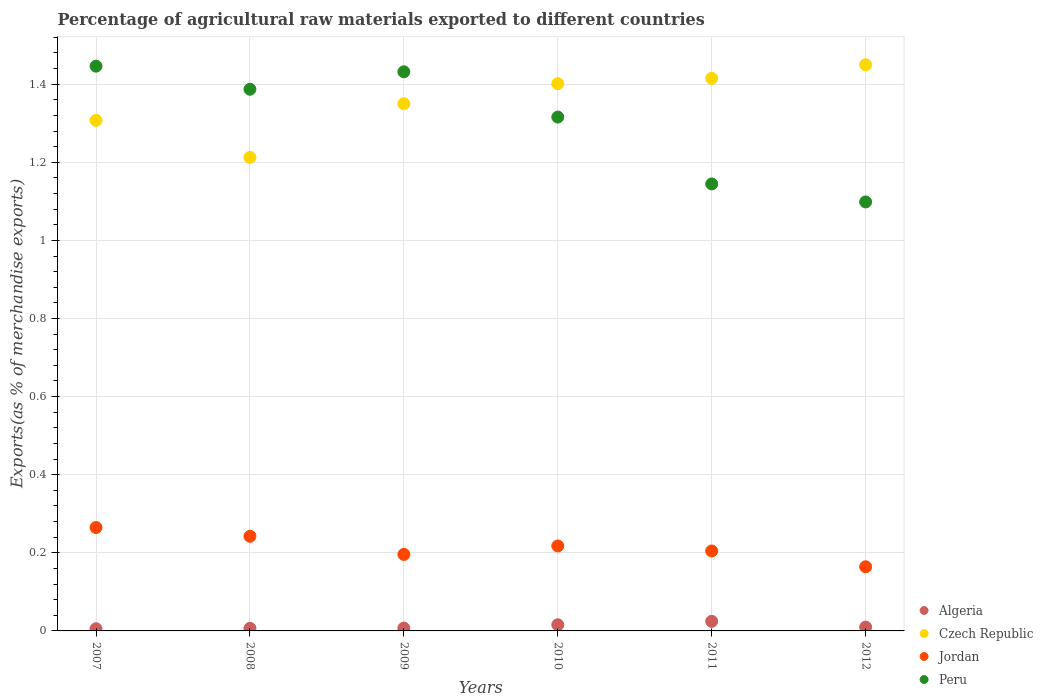How many different coloured dotlines are there?
Keep it short and to the point. 4. What is the percentage of exports to different countries in Czech Republic in 2012?
Offer a very short reply. 1.45. Across all years, what is the maximum percentage of exports to different countries in Czech Republic?
Give a very brief answer. 1.45. Across all years, what is the minimum percentage of exports to different countries in Czech Republic?
Provide a succinct answer. 1.21. In which year was the percentage of exports to different countries in Algeria maximum?
Make the answer very short. 2011. In which year was the percentage of exports to different countries in Czech Republic minimum?
Give a very brief answer. 2008. What is the total percentage of exports to different countries in Jordan in the graph?
Make the answer very short. 1.29. What is the difference between the percentage of exports to different countries in Algeria in 2007 and that in 2008?
Your answer should be compact. -0. What is the difference between the percentage of exports to different countries in Peru in 2011 and the percentage of exports to different countries in Jordan in 2010?
Provide a succinct answer. 0.93. What is the average percentage of exports to different countries in Czech Republic per year?
Your answer should be very brief. 1.36. In the year 2010, what is the difference between the percentage of exports to different countries in Algeria and percentage of exports to different countries in Peru?
Keep it short and to the point. -1.3. In how many years, is the percentage of exports to different countries in Peru greater than 0.56 %?
Your answer should be compact. 6. What is the ratio of the percentage of exports to different countries in Czech Republic in 2009 to that in 2010?
Give a very brief answer. 0.96. Is the difference between the percentage of exports to different countries in Algeria in 2007 and 2012 greater than the difference between the percentage of exports to different countries in Peru in 2007 and 2012?
Your response must be concise. No. What is the difference between the highest and the second highest percentage of exports to different countries in Jordan?
Your response must be concise. 0.02. What is the difference between the highest and the lowest percentage of exports to different countries in Jordan?
Your answer should be compact. 0.1. Is it the case that in every year, the sum of the percentage of exports to different countries in Peru and percentage of exports to different countries in Algeria  is greater than the sum of percentage of exports to different countries in Jordan and percentage of exports to different countries in Czech Republic?
Provide a short and direct response. No. Is the percentage of exports to different countries in Jordan strictly greater than the percentage of exports to different countries in Czech Republic over the years?
Offer a terse response. No. Is the percentage of exports to different countries in Czech Republic strictly less than the percentage of exports to different countries in Jordan over the years?
Your answer should be compact. No. What is the difference between two consecutive major ticks on the Y-axis?
Offer a very short reply. 0.2. Where does the legend appear in the graph?
Provide a short and direct response. Bottom right. How many legend labels are there?
Provide a short and direct response. 4. What is the title of the graph?
Offer a very short reply. Percentage of agricultural raw materials exported to different countries. What is the label or title of the X-axis?
Your response must be concise. Years. What is the label or title of the Y-axis?
Your answer should be compact. Exports(as % of merchandise exports). What is the Exports(as % of merchandise exports) in Algeria in 2007?
Provide a short and direct response. 0.01. What is the Exports(as % of merchandise exports) in Czech Republic in 2007?
Give a very brief answer. 1.31. What is the Exports(as % of merchandise exports) of Jordan in 2007?
Give a very brief answer. 0.26. What is the Exports(as % of merchandise exports) in Peru in 2007?
Offer a very short reply. 1.45. What is the Exports(as % of merchandise exports) in Algeria in 2008?
Offer a very short reply. 0.01. What is the Exports(as % of merchandise exports) of Czech Republic in 2008?
Make the answer very short. 1.21. What is the Exports(as % of merchandise exports) in Jordan in 2008?
Give a very brief answer. 0.24. What is the Exports(as % of merchandise exports) in Peru in 2008?
Offer a very short reply. 1.39. What is the Exports(as % of merchandise exports) of Algeria in 2009?
Your answer should be compact. 0.01. What is the Exports(as % of merchandise exports) of Czech Republic in 2009?
Give a very brief answer. 1.35. What is the Exports(as % of merchandise exports) of Jordan in 2009?
Give a very brief answer. 0.2. What is the Exports(as % of merchandise exports) of Peru in 2009?
Provide a short and direct response. 1.43. What is the Exports(as % of merchandise exports) of Algeria in 2010?
Offer a terse response. 0.02. What is the Exports(as % of merchandise exports) of Czech Republic in 2010?
Keep it short and to the point. 1.4. What is the Exports(as % of merchandise exports) of Jordan in 2010?
Offer a terse response. 0.22. What is the Exports(as % of merchandise exports) of Peru in 2010?
Provide a short and direct response. 1.32. What is the Exports(as % of merchandise exports) of Algeria in 2011?
Provide a short and direct response. 0.02. What is the Exports(as % of merchandise exports) in Czech Republic in 2011?
Your answer should be compact. 1.41. What is the Exports(as % of merchandise exports) of Jordan in 2011?
Give a very brief answer. 0.2. What is the Exports(as % of merchandise exports) of Peru in 2011?
Provide a short and direct response. 1.14. What is the Exports(as % of merchandise exports) in Algeria in 2012?
Offer a very short reply. 0.01. What is the Exports(as % of merchandise exports) of Czech Republic in 2012?
Provide a succinct answer. 1.45. What is the Exports(as % of merchandise exports) in Jordan in 2012?
Make the answer very short. 0.16. What is the Exports(as % of merchandise exports) of Peru in 2012?
Offer a very short reply. 1.1. Across all years, what is the maximum Exports(as % of merchandise exports) of Algeria?
Your response must be concise. 0.02. Across all years, what is the maximum Exports(as % of merchandise exports) of Czech Republic?
Offer a terse response. 1.45. Across all years, what is the maximum Exports(as % of merchandise exports) of Jordan?
Offer a terse response. 0.26. Across all years, what is the maximum Exports(as % of merchandise exports) in Peru?
Keep it short and to the point. 1.45. Across all years, what is the minimum Exports(as % of merchandise exports) in Algeria?
Offer a terse response. 0.01. Across all years, what is the minimum Exports(as % of merchandise exports) in Czech Republic?
Make the answer very short. 1.21. Across all years, what is the minimum Exports(as % of merchandise exports) of Jordan?
Provide a succinct answer. 0.16. Across all years, what is the minimum Exports(as % of merchandise exports) of Peru?
Offer a terse response. 1.1. What is the total Exports(as % of merchandise exports) in Algeria in the graph?
Your response must be concise. 0.07. What is the total Exports(as % of merchandise exports) in Czech Republic in the graph?
Offer a very short reply. 8.14. What is the total Exports(as % of merchandise exports) in Jordan in the graph?
Provide a succinct answer. 1.29. What is the total Exports(as % of merchandise exports) of Peru in the graph?
Your answer should be very brief. 7.82. What is the difference between the Exports(as % of merchandise exports) in Algeria in 2007 and that in 2008?
Your answer should be very brief. -0. What is the difference between the Exports(as % of merchandise exports) in Czech Republic in 2007 and that in 2008?
Offer a terse response. 0.1. What is the difference between the Exports(as % of merchandise exports) in Jordan in 2007 and that in 2008?
Offer a very short reply. 0.02. What is the difference between the Exports(as % of merchandise exports) in Peru in 2007 and that in 2008?
Make the answer very short. 0.06. What is the difference between the Exports(as % of merchandise exports) in Algeria in 2007 and that in 2009?
Provide a succinct answer. -0. What is the difference between the Exports(as % of merchandise exports) of Czech Republic in 2007 and that in 2009?
Provide a succinct answer. -0.04. What is the difference between the Exports(as % of merchandise exports) of Jordan in 2007 and that in 2009?
Give a very brief answer. 0.07. What is the difference between the Exports(as % of merchandise exports) in Peru in 2007 and that in 2009?
Ensure brevity in your answer.  0.01. What is the difference between the Exports(as % of merchandise exports) of Algeria in 2007 and that in 2010?
Provide a succinct answer. -0.01. What is the difference between the Exports(as % of merchandise exports) in Czech Republic in 2007 and that in 2010?
Make the answer very short. -0.09. What is the difference between the Exports(as % of merchandise exports) of Jordan in 2007 and that in 2010?
Offer a terse response. 0.05. What is the difference between the Exports(as % of merchandise exports) of Peru in 2007 and that in 2010?
Ensure brevity in your answer.  0.13. What is the difference between the Exports(as % of merchandise exports) in Algeria in 2007 and that in 2011?
Your answer should be very brief. -0.02. What is the difference between the Exports(as % of merchandise exports) of Czech Republic in 2007 and that in 2011?
Your answer should be compact. -0.11. What is the difference between the Exports(as % of merchandise exports) of Jordan in 2007 and that in 2011?
Ensure brevity in your answer.  0.06. What is the difference between the Exports(as % of merchandise exports) in Peru in 2007 and that in 2011?
Keep it short and to the point. 0.3. What is the difference between the Exports(as % of merchandise exports) of Algeria in 2007 and that in 2012?
Ensure brevity in your answer.  -0. What is the difference between the Exports(as % of merchandise exports) of Czech Republic in 2007 and that in 2012?
Offer a very short reply. -0.14. What is the difference between the Exports(as % of merchandise exports) of Jordan in 2007 and that in 2012?
Provide a short and direct response. 0.1. What is the difference between the Exports(as % of merchandise exports) in Peru in 2007 and that in 2012?
Keep it short and to the point. 0.35. What is the difference between the Exports(as % of merchandise exports) of Algeria in 2008 and that in 2009?
Offer a terse response. -0. What is the difference between the Exports(as % of merchandise exports) of Czech Republic in 2008 and that in 2009?
Give a very brief answer. -0.14. What is the difference between the Exports(as % of merchandise exports) in Jordan in 2008 and that in 2009?
Your answer should be compact. 0.05. What is the difference between the Exports(as % of merchandise exports) in Peru in 2008 and that in 2009?
Ensure brevity in your answer.  -0.04. What is the difference between the Exports(as % of merchandise exports) in Algeria in 2008 and that in 2010?
Provide a short and direct response. -0.01. What is the difference between the Exports(as % of merchandise exports) in Czech Republic in 2008 and that in 2010?
Your response must be concise. -0.19. What is the difference between the Exports(as % of merchandise exports) in Jordan in 2008 and that in 2010?
Offer a very short reply. 0.02. What is the difference between the Exports(as % of merchandise exports) of Peru in 2008 and that in 2010?
Your answer should be compact. 0.07. What is the difference between the Exports(as % of merchandise exports) of Algeria in 2008 and that in 2011?
Your answer should be compact. -0.02. What is the difference between the Exports(as % of merchandise exports) of Czech Republic in 2008 and that in 2011?
Your response must be concise. -0.2. What is the difference between the Exports(as % of merchandise exports) in Jordan in 2008 and that in 2011?
Offer a very short reply. 0.04. What is the difference between the Exports(as % of merchandise exports) in Peru in 2008 and that in 2011?
Offer a very short reply. 0.24. What is the difference between the Exports(as % of merchandise exports) of Algeria in 2008 and that in 2012?
Your answer should be very brief. -0. What is the difference between the Exports(as % of merchandise exports) in Czech Republic in 2008 and that in 2012?
Keep it short and to the point. -0.24. What is the difference between the Exports(as % of merchandise exports) of Jordan in 2008 and that in 2012?
Keep it short and to the point. 0.08. What is the difference between the Exports(as % of merchandise exports) of Peru in 2008 and that in 2012?
Provide a short and direct response. 0.29. What is the difference between the Exports(as % of merchandise exports) in Algeria in 2009 and that in 2010?
Make the answer very short. -0.01. What is the difference between the Exports(as % of merchandise exports) of Czech Republic in 2009 and that in 2010?
Your answer should be very brief. -0.05. What is the difference between the Exports(as % of merchandise exports) in Jordan in 2009 and that in 2010?
Offer a very short reply. -0.02. What is the difference between the Exports(as % of merchandise exports) in Peru in 2009 and that in 2010?
Offer a terse response. 0.12. What is the difference between the Exports(as % of merchandise exports) of Algeria in 2009 and that in 2011?
Keep it short and to the point. -0.02. What is the difference between the Exports(as % of merchandise exports) of Czech Republic in 2009 and that in 2011?
Provide a short and direct response. -0.06. What is the difference between the Exports(as % of merchandise exports) of Jordan in 2009 and that in 2011?
Keep it short and to the point. -0.01. What is the difference between the Exports(as % of merchandise exports) of Peru in 2009 and that in 2011?
Make the answer very short. 0.29. What is the difference between the Exports(as % of merchandise exports) of Algeria in 2009 and that in 2012?
Offer a very short reply. -0. What is the difference between the Exports(as % of merchandise exports) of Czech Republic in 2009 and that in 2012?
Provide a succinct answer. -0.1. What is the difference between the Exports(as % of merchandise exports) of Jordan in 2009 and that in 2012?
Your answer should be compact. 0.03. What is the difference between the Exports(as % of merchandise exports) in Algeria in 2010 and that in 2011?
Your response must be concise. -0.01. What is the difference between the Exports(as % of merchandise exports) in Czech Republic in 2010 and that in 2011?
Offer a terse response. -0.01. What is the difference between the Exports(as % of merchandise exports) of Jordan in 2010 and that in 2011?
Offer a terse response. 0.01. What is the difference between the Exports(as % of merchandise exports) in Peru in 2010 and that in 2011?
Your answer should be very brief. 0.17. What is the difference between the Exports(as % of merchandise exports) in Algeria in 2010 and that in 2012?
Make the answer very short. 0.01. What is the difference between the Exports(as % of merchandise exports) of Czech Republic in 2010 and that in 2012?
Your response must be concise. -0.05. What is the difference between the Exports(as % of merchandise exports) of Jordan in 2010 and that in 2012?
Make the answer very short. 0.05. What is the difference between the Exports(as % of merchandise exports) of Peru in 2010 and that in 2012?
Ensure brevity in your answer.  0.22. What is the difference between the Exports(as % of merchandise exports) of Algeria in 2011 and that in 2012?
Give a very brief answer. 0.01. What is the difference between the Exports(as % of merchandise exports) of Czech Republic in 2011 and that in 2012?
Give a very brief answer. -0.03. What is the difference between the Exports(as % of merchandise exports) in Jordan in 2011 and that in 2012?
Ensure brevity in your answer.  0.04. What is the difference between the Exports(as % of merchandise exports) of Peru in 2011 and that in 2012?
Ensure brevity in your answer.  0.05. What is the difference between the Exports(as % of merchandise exports) of Algeria in 2007 and the Exports(as % of merchandise exports) of Czech Republic in 2008?
Provide a short and direct response. -1.21. What is the difference between the Exports(as % of merchandise exports) of Algeria in 2007 and the Exports(as % of merchandise exports) of Jordan in 2008?
Offer a terse response. -0.24. What is the difference between the Exports(as % of merchandise exports) in Algeria in 2007 and the Exports(as % of merchandise exports) in Peru in 2008?
Offer a very short reply. -1.38. What is the difference between the Exports(as % of merchandise exports) in Czech Republic in 2007 and the Exports(as % of merchandise exports) in Jordan in 2008?
Provide a short and direct response. 1.07. What is the difference between the Exports(as % of merchandise exports) of Czech Republic in 2007 and the Exports(as % of merchandise exports) of Peru in 2008?
Give a very brief answer. -0.08. What is the difference between the Exports(as % of merchandise exports) in Jordan in 2007 and the Exports(as % of merchandise exports) in Peru in 2008?
Give a very brief answer. -1.12. What is the difference between the Exports(as % of merchandise exports) in Algeria in 2007 and the Exports(as % of merchandise exports) in Czech Republic in 2009?
Make the answer very short. -1.34. What is the difference between the Exports(as % of merchandise exports) in Algeria in 2007 and the Exports(as % of merchandise exports) in Jordan in 2009?
Make the answer very short. -0.19. What is the difference between the Exports(as % of merchandise exports) of Algeria in 2007 and the Exports(as % of merchandise exports) of Peru in 2009?
Provide a succinct answer. -1.43. What is the difference between the Exports(as % of merchandise exports) in Czech Republic in 2007 and the Exports(as % of merchandise exports) in Jordan in 2009?
Your response must be concise. 1.11. What is the difference between the Exports(as % of merchandise exports) of Czech Republic in 2007 and the Exports(as % of merchandise exports) of Peru in 2009?
Provide a succinct answer. -0.12. What is the difference between the Exports(as % of merchandise exports) in Jordan in 2007 and the Exports(as % of merchandise exports) in Peru in 2009?
Provide a short and direct response. -1.17. What is the difference between the Exports(as % of merchandise exports) in Algeria in 2007 and the Exports(as % of merchandise exports) in Czech Republic in 2010?
Your response must be concise. -1.4. What is the difference between the Exports(as % of merchandise exports) of Algeria in 2007 and the Exports(as % of merchandise exports) of Jordan in 2010?
Make the answer very short. -0.21. What is the difference between the Exports(as % of merchandise exports) of Algeria in 2007 and the Exports(as % of merchandise exports) of Peru in 2010?
Make the answer very short. -1.31. What is the difference between the Exports(as % of merchandise exports) in Czech Republic in 2007 and the Exports(as % of merchandise exports) in Jordan in 2010?
Ensure brevity in your answer.  1.09. What is the difference between the Exports(as % of merchandise exports) in Czech Republic in 2007 and the Exports(as % of merchandise exports) in Peru in 2010?
Your answer should be very brief. -0.01. What is the difference between the Exports(as % of merchandise exports) of Jordan in 2007 and the Exports(as % of merchandise exports) of Peru in 2010?
Offer a terse response. -1.05. What is the difference between the Exports(as % of merchandise exports) in Algeria in 2007 and the Exports(as % of merchandise exports) in Czech Republic in 2011?
Offer a very short reply. -1.41. What is the difference between the Exports(as % of merchandise exports) of Algeria in 2007 and the Exports(as % of merchandise exports) of Jordan in 2011?
Ensure brevity in your answer.  -0.2. What is the difference between the Exports(as % of merchandise exports) of Algeria in 2007 and the Exports(as % of merchandise exports) of Peru in 2011?
Ensure brevity in your answer.  -1.14. What is the difference between the Exports(as % of merchandise exports) of Czech Republic in 2007 and the Exports(as % of merchandise exports) of Jordan in 2011?
Offer a terse response. 1.1. What is the difference between the Exports(as % of merchandise exports) of Czech Republic in 2007 and the Exports(as % of merchandise exports) of Peru in 2011?
Offer a very short reply. 0.16. What is the difference between the Exports(as % of merchandise exports) of Jordan in 2007 and the Exports(as % of merchandise exports) of Peru in 2011?
Ensure brevity in your answer.  -0.88. What is the difference between the Exports(as % of merchandise exports) in Algeria in 2007 and the Exports(as % of merchandise exports) in Czech Republic in 2012?
Your answer should be very brief. -1.44. What is the difference between the Exports(as % of merchandise exports) of Algeria in 2007 and the Exports(as % of merchandise exports) of Jordan in 2012?
Give a very brief answer. -0.16. What is the difference between the Exports(as % of merchandise exports) of Algeria in 2007 and the Exports(as % of merchandise exports) of Peru in 2012?
Make the answer very short. -1.09. What is the difference between the Exports(as % of merchandise exports) in Czech Republic in 2007 and the Exports(as % of merchandise exports) in Jordan in 2012?
Offer a terse response. 1.14. What is the difference between the Exports(as % of merchandise exports) of Czech Republic in 2007 and the Exports(as % of merchandise exports) of Peru in 2012?
Offer a very short reply. 0.21. What is the difference between the Exports(as % of merchandise exports) in Jordan in 2007 and the Exports(as % of merchandise exports) in Peru in 2012?
Your answer should be compact. -0.83. What is the difference between the Exports(as % of merchandise exports) in Algeria in 2008 and the Exports(as % of merchandise exports) in Czech Republic in 2009?
Your answer should be compact. -1.34. What is the difference between the Exports(as % of merchandise exports) in Algeria in 2008 and the Exports(as % of merchandise exports) in Jordan in 2009?
Provide a short and direct response. -0.19. What is the difference between the Exports(as % of merchandise exports) in Algeria in 2008 and the Exports(as % of merchandise exports) in Peru in 2009?
Your response must be concise. -1.43. What is the difference between the Exports(as % of merchandise exports) in Czech Republic in 2008 and the Exports(as % of merchandise exports) in Jordan in 2009?
Provide a succinct answer. 1.02. What is the difference between the Exports(as % of merchandise exports) of Czech Republic in 2008 and the Exports(as % of merchandise exports) of Peru in 2009?
Make the answer very short. -0.22. What is the difference between the Exports(as % of merchandise exports) of Jordan in 2008 and the Exports(as % of merchandise exports) of Peru in 2009?
Make the answer very short. -1.19. What is the difference between the Exports(as % of merchandise exports) of Algeria in 2008 and the Exports(as % of merchandise exports) of Czech Republic in 2010?
Provide a succinct answer. -1.39. What is the difference between the Exports(as % of merchandise exports) of Algeria in 2008 and the Exports(as % of merchandise exports) of Jordan in 2010?
Ensure brevity in your answer.  -0.21. What is the difference between the Exports(as % of merchandise exports) of Algeria in 2008 and the Exports(as % of merchandise exports) of Peru in 2010?
Your answer should be compact. -1.31. What is the difference between the Exports(as % of merchandise exports) in Czech Republic in 2008 and the Exports(as % of merchandise exports) in Peru in 2010?
Provide a succinct answer. -0.1. What is the difference between the Exports(as % of merchandise exports) of Jordan in 2008 and the Exports(as % of merchandise exports) of Peru in 2010?
Your response must be concise. -1.07. What is the difference between the Exports(as % of merchandise exports) of Algeria in 2008 and the Exports(as % of merchandise exports) of Czech Republic in 2011?
Give a very brief answer. -1.41. What is the difference between the Exports(as % of merchandise exports) in Algeria in 2008 and the Exports(as % of merchandise exports) in Jordan in 2011?
Keep it short and to the point. -0.2. What is the difference between the Exports(as % of merchandise exports) in Algeria in 2008 and the Exports(as % of merchandise exports) in Peru in 2011?
Your answer should be very brief. -1.14. What is the difference between the Exports(as % of merchandise exports) in Czech Republic in 2008 and the Exports(as % of merchandise exports) in Jordan in 2011?
Offer a terse response. 1.01. What is the difference between the Exports(as % of merchandise exports) of Czech Republic in 2008 and the Exports(as % of merchandise exports) of Peru in 2011?
Ensure brevity in your answer.  0.07. What is the difference between the Exports(as % of merchandise exports) of Jordan in 2008 and the Exports(as % of merchandise exports) of Peru in 2011?
Offer a very short reply. -0.9. What is the difference between the Exports(as % of merchandise exports) in Algeria in 2008 and the Exports(as % of merchandise exports) in Czech Republic in 2012?
Give a very brief answer. -1.44. What is the difference between the Exports(as % of merchandise exports) in Algeria in 2008 and the Exports(as % of merchandise exports) in Jordan in 2012?
Your response must be concise. -0.16. What is the difference between the Exports(as % of merchandise exports) of Algeria in 2008 and the Exports(as % of merchandise exports) of Peru in 2012?
Ensure brevity in your answer.  -1.09. What is the difference between the Exports(as % of merchandise exports) in Czech Republic in 2008 and the Exports(as % of merchandise exports) in Jordan in 2012?
Your answer should be compact. 1.05. What is the difference between the Exports(as % of merchandise exports) in Czech Republic in 2008 and the Exports(as % of merchandise exports) in Peru in 2012?
Your answer should be compact. 0.11. What is the difference between the Exports(as % of merchandise exports) of Jordan in 2008 and the Exports(as % of merchandise exports) of Peru in 2012?
Make the answer very short. -0.86. What is the difference between the Exports(as % of merchandise exports) in Algeria in 2009 and the Exports(as % of merchandise exports) in Czech Republic in 2010?
Make the answer very short. -1.39. What is the difference between the Exports(as % of merchandise exports) of Algeria in 2009 and the Exports(as % of merchandise exports) of Jordan in 2010?
Offer a terse response. -0.21. What is the difference between the Exports(as % of merchandise exports) in Algeria in 2009 and the Exports(as % of merchandise exports) in Peru in 2010?
Make the answer very short. -1.31. What is the difference between the Exports(as % of merchandise exports) of Czech Republic in 2009 and the Exports(as % of merchandise exports) of Jordan in 2010?
Your answer should be very brief. 1.13. What is the difference between the Exports(as % of merchandise exports) in Czech Republic in 2009 and the Exports(as % of merchandise exports) in Peru in 2010?
Offer a terse response. 0.03. What is the difference between the Exports(as % of merchandise exports) in Jordan in 2009 and the Exports(as % of merchandise exports) in Peru in 2010?
Keep it short and to the point. -1.12. What is the difference between the Exports(as % of merchandise exports) in Algeria in 2009 and the Exports(as % of merchandise exports) in Czech Republic in 2011?
Give a very brief answer. -1.41. What is the difference between the Exports(as % of merchandise exports) of Algeria in 2009 and the Exports(as % of merchandise exports) of Jordan in 2011?
Ensure brevity in your answer.  -0.2. What is the difference between the Exports(as % of merchandise exports) in Algeria in 2009 and the Exports(as % of merchandise exports) in Peru in 2011?
Offer a very short reply. -1.14. What is the difference between the Exports(as % of merchandise exports) in Czech Republic in 2009 and the Exports(as % of merchandise exports) in Jordan in 2011?
Your answer should be compact. 1.15. What is the difference between the Exports(as % of merchandise exports) of Czech Republic in 2009 and the Exports(as % of merchandise exports) of Peru in 2011?
Offer a terse response. 0.21. What is the difference between the Exports(as % of merchandise exports) in Jordan in 2009 and the Exports(as % of merchandise exports) in Peru in 2011?
Your answer should be compact. -0.95. What is the difference between the Exports(as % of merchandise exports) in Algeria in 2009 and the Exports(as % of merchandise exports) in Czech Republic in 2012?
Offer a terse response. -1.44. What is the difference between the Exports(as % of merchandise exports) in Algeria in 2009 and the Exports(as % of merchandise exports) in Jordan in 2012?
Offer a very short reply. -0.16. What is the difference between the Exports(as % of merchandise exports) in Algeria in 2009 and the Exports(as % of merchandise exports) in Peru in 2012?
Offer a very short reply. -1.09. What is the difference between the Exports(as % of merchandise exports) of Czech Republic in 2009 and the Exports(as % of merchandise exports) of Jordan in 2012?
Offer a very short reply. 1.19. What is the difference between the Exports(as % of merchandise exports) in Czech Republic in 2009 and the Exports(as % of merchandise exports) in Peru in 2012?
Provide a short and direct response. 0.25. What is the difference between the Exports(as % of merchandise exports) of Jordan in 2009 and the Exports(as % of merchandise exports) of Peru in 2012?
Offer a terse response. -0.9. What is the difference between the Exports(as % of merchandise exports) in Algeria in 2010 and the Exports(as % of merchandise exports) in Czech Republic in 2011?
Offer a terse response. -1.4. What is the difference between the Exports(as % of merchandise exports) in Algeria in 2010 and the Exports(as % of merchandise exports) in Jordan in 2011?
Make the answer very short. -0.19. What is the difference between the Exports(as % of merchandise exports) of Algeria in 2010 and the Exports(as % of merchandise exports) of Peru in 2011?
Your answer should be very brief. -1.13. What is the difference between the Exports(as % of merchandise exports) of Czech Republic in 2010 and the Exports(as % of merchandise exports) of Jordan in 2011?
Offer a very short reply. 1.2. What is the difference between the Exports(as % of merchandise exports) of Czech Republic in 2010 and the Exports(as % of merchandise exports) of Peru in 2011?
Offer a terse response. 0.26. What is the difference between the Exports(as % of merchandise exports) of Jordan in 2010 and the Exports(as % of merchandise exports) of Peru in 2011?
Offer a very short reply. -0.93. What is the difference between the Exports(as % of merchandise exports) in Algeria in 2010 and the Exports(as % of merchandise exports) in Czech Republic in 2012?
Your answer should be compact. -1.43. What is the difference between the Exports(as % of merchandise exports) in Algeria in 2010 and the Exports(as % of merchandise exports) in Jordan in 2012?
Your answer should be compact. -0.15. What is the difference between the Exports(as % of merchandise exports) of Algeria in 2010 and the Exports(as % of merchandise exports) of Peru in 2012?
Your response must be concise. -1.08. What is the difference between the Exports(as % of merchandise exports) in Czech Republic in 2010 and the Exports(as % of merchandise exports) in Jordan in 2012?
Your answer should be compact. 1.24. What is the difference between the Exports(as % of merchandise exports) in Czech Republic in 2010 and the Exports(as % of merchandise exports) in Peru in 2012?
Offer a terse response. 0.3. What is the difference between the Exports(as % of merchandise exports) in Jordan in 2010 and the Exports(as % of merchandise exports) in Peru in 2012?
Make the answer very short. -0.88. What is the difference between the Exports(as % of merchandise exports) in Algeria in 2011 and the Exports(as % of merchandise exports) in Czech Republic in 2012?
Offer a very short reply. -1.43. What is the difference between the Exports(as % of merchandise exports) of Algeria in 2011 and the Exports(as % of merchandise exports) of Jordan in 2012?
Provide a succinct answer. -0.14. What is the difference between the Exports(as % of merchandise exports) in Algeria in 2011 and the Exports(as % of merchandise exports) in Peru in 2012?
Provide a short and direct response. -1.07. What is the difference between the Exports(as % of merchandise exports) in Czech Republic in 2011 and the Exports(as % of merchandise exports) in Jordan in 2012?
Keep it short and to the point. 1.25. What is the difference between the Exports(as % of merchandise exports) of Czech Republic in 2011 and the Exports(as % of merchandise exports) of Peru in 2012?
Ensure brevity in your answer.  0.32. What is the difference between the Exports(as % of merchandise exports) of Jordan in 2011 and the Exports(as % of merchandise exports) of Peru in 2012?
Make the answer very short. -0.89. What is the average Exports(as % of merchandise exports) in Algeria per year?
Your answer should be compact. 0.01. What is the average Exports(as % of merchandise exports) of Czech Republic per year?
Your response must be concise. 1.36. What is the average Exports(as % of merchandise exports) in Jordan per year?
Give a very brief answer. 0.21. What is the average Exports(as % of merchandise exports) of Peru per year?
Offer a very short reply. 1.3. In the year 2007, what is the difference between the Exports(as % of merchandise exports) of Algeria and Exports(as % of merchandise exports) of Czech Republic?
Provide a short and direct response. -1.3. In the year 2007, what is the difference between the Exports(as % of merchandise exports) of Algeria and Exports(as % of merchandise exports) of Jordan?
Offer a very short reply. -0.26. In the year 2007, what is the difference between the Exports(as % of merchandise exports) of Algeria and Exports(as % of merchandise exports) of Peru?
Offer a terse response. -1.44. In the year 2007, what is the difference between the Exports(as % of merchandise exports) of Czech Republic and Exports(as % of merchandise exports) of Jordan?
Your answer should be very brief. 1.04. In the year 2007, what is the difference between the Exports(as % of merchandise exports) of Czech Republic and Exports(as % of merchandise exports) of Peru?
Your answer should be very brief. -0.14. In the year 2007, what is the difference between the Exports(as % of merchandise exports) of Jordan and Exports(as % of merchandise exports) of Peru?
Your answer should be compact. -1.18. In the year 2008, what is the difference between the Exports(as % of merchandise exports) in Algeria and Exports(as % of merchandise exports) in Czech Republic?
Your answer should be very brief. -1.21. In the year 2008, what is the difference between the Exports(as % of merchandise exports) in Algeria and Exports(as % of merchandise exports) in Jordan?
Your answer should be compact. -0.24. In the year 2008, what is the difference between the Exports(as % of merchandise exports) of Algeria and Exports(as % of merchandise exports) of Peru?
Ensure brevity in your answer.  -1.38. In the year 2008, what is the difference between the Exports(as % of merchandise exports) in Czech Republic and Exports(as % of merchandise exports) in Jordan?
Keep it short and to the point. 0.97. In the year 2008, what is the difference between the Exports(as % of merchandise exports) in Czech Republic and Exports(as % of merchandise exports) in Peru?
Keep it short and to the point. -0.17. In the year 2008, what is the difference between the Exports(as % of merchandise exports) in Jordan and Exports(as % of merchandise exports) in Peru?
Ensure brevity in your answer.  -1.14. In the year 2009, what is the difference between the Exports(as % of merchandise exports) in Algeria and Exports(as % of merchandise exports) in Czech Republic?
Your response must be concise. -1.34. In the year 2009, what is the difference between the Exports(as % of merchandise exports) in Algeria and Exports(as % of merchandise exports) in Jordan?
Provide a short and direct response. -0.19. In the year 2009, what is the difference between the Exports(as % of merchandise exports) of Algeria and Exports(as % of merchandise exports) of Peru?
Provide a short and direct response. -1.42. In the year 2009, what is the difference between the Exports(as % of merchandise exports) of Czech Republic and Exports(as % of merchandise exports) of Jordan?
Your answer should be compact. 1.15. In the year 2009, what is the difference between the Exports(as % of merchandise exports) in Czech Republic and Exports(as % of merchandise exports) in Peru?
Your answer should be very brief. -0.08. In the year 2009, what is the difference between the Exports(as % of merchandise exports) of Jordan and Exports(as % of merchandise exports) of Peru?
Your answer should be compact. -1.24. In the year 2010, what is the difference between the Exports(as % of merchandise exports) of Algeria and Exports(as % of merchandise exports) of Czech Republic?
Make the answer very short. -1.39. In the year 2010, what is the difference between the Exports(as % of merchandise exports) in Algeria and Exports(as % of merchandise exports) in Jordan?
Give a very brief answer. -0.2. In the year 2010, what is the difference between the Exports(as % of merchandise exports) of Algeria and Exports(as % of merchandise exports) of Peru?
Your response must be concise. -1.3. In the year 2010, what is the difference between the Exports(as % of merchandise exports) of Czech Republic and Exports(as % of merchandise exports) of Jordan?
Offer a very short reply. 1.18. In the year 2010, what is the difference between the Exports(as % of merchandise exports) of Czech Republic and Exports(as % of merchandise exports) of Peru?
Give a very brief answer. 0.09. In the year 2010, what is the difference between the Exports(as % of merchandise exports) in Jordan and Exports(as % of merchandise exports) in Peru?
Your response must be concise. -1.1. In the year 2011, what is the difference between the Exports(as % of merchandise exports) of Algeria and Exports(as % of merchandise exports) of Czech Republic?
Offer a terse response. -1.39. In the year 2011, what is the difference between the Exports(as % of merchandise exports) of Algeria and Exports(as % of merchandise exports) of Jordan?
Provide a succinct answer. -0.18. In the year 2011, what is the difference between the Exports(as % of merchandise exports) in Algeria and Exports(as % of merchandise exports) in Peru?
Give a very brief answer. -1.12. In the year 2011, what is the difference between the Exports(as % of merchandise exports) in Czech Republic and Exports(as % of merchandise exports) in Jordan?
Your answer should be very brief. 1.21. In the year 2011, what is the difference between the Exports(as % of merchandise exports) of Czech Republic and Exports(as % of merchandise exports) of Peru?
Offer a very short reply. 0.27. In the year 2011, what is the difference between the Exports(as % of merchandise exports) of Jordan and Exports(as % of merchandise exports) of Peru?
Give a very brief answer. -0.94. In the year 2012, what is the difference between the Exports(as % of merchandise exports) of Algeria and Exports(as % of merchandise exports) of Czech Republic?
Ensure brevity in your answer.  -1.44. In the year 2012, what is the difference between the Exports(as % of merchandise exports) of Algeria and Exports(as % of merchandise exports) of Jordan?
Offer a terse response. -0.15. In the year 2012, what is the difference between the Exports(as % of merchandise exports) in Algeria and Exports(as % of merchandise exports) in Peru?
Keep it short and to the point. -1.09. In the year 2012, what is the difference between the Exports(as % of merchandise exports) in Czech Republic and Exports(as % of merchandise exports) in Jordan?
Ensure brevity in your answer.  1.29. In the year 2012, what is the difference between the Exports(as % of merchandise exports) in Czech Republic and Exports(as % of merchandise exports) in Peru?
Provide a short and direct response. 0.35. In the year 2012, what is the difference between the Exports(as % of merchandise exports) in Jordan and Exports(as % of merchandise exports) in Peru?
Make the answer very short. -0.93. What is the ratio of the Exports(as % of merchandise exports) of Algeria in 2007 to that in 2008?
Your response must be concise. 0.84. What is the ratio of the Exports(as % of merchandise exports) in Czech Republic in 2007 to that in 2008?
Your answer should be compact. 1.08. What is the ratio of the Exports(as % of merchandise exports) in Jordan in 2007 to that in 2008?
Your answer should be very brief. 1.09. What is the ratio of the Exports(as % of merchandise exports) in Peru in 2007 to that in 2008?
Offer a very short reply. 1.04. What is the ratio of the Exports(as % of merchandise exports) of Algeria in 2007 to that in 2009?
Provide a short and direct response. 0.76. What is the ratio of the Exports(as % of merchandise exports) of Czech Republic in 2007 to that in 2009?
Keep it short and to the point. 0.97. What is the ratio of the Exports(as % of merchandise exports) of Jordan in 2007 to that in 2009?
Provide a short and direct response. 1.35. What is the ratio of the Exports(as % of merchandise exports) in Algeria in 2007 to that in 2010?
Your answer should be very brief. 0.35. What is the ratio of the Exports(as % of merchandise exports) of Czech Republic in 2007 to that in 2010?
Keep it short and to the point. 0.93. What is the ratio of the Exports(as % of merchandise exports) in Jordan in 2007 to that in 2010?
Your answer should be compact. 1.22. What is the ratio of the Exports(as % of merchandise exports) in Peru in 2007 to that in 2010?
Offer a terse response. 1.1. What is the ratio of the Exports(as % of merchandise exports) in Algeria in 2007 to that in 2011?
Provide a short and direct response. 0.23. What is the ratio of the Exports(as % of merchandise exports) in Czech Republic in 2007 to that in 2011?
Provide a succinct answer. 0.92. What is the ratio of the Exports(as % of merchandise exports) of Jordan in 2007 to that in 2011?
Ensure brevity in your answer.  1.29. What is the ratio of the Exports(as % of merchandise exports) of Peru in 2007 to that in 2011?
Your answer should be very brief. 1.26. What is the ratio of the Exports(as % of merchandise exports) of Algeria in 2007 to that in 2012?
Make the answer very short. 0.57. What is the ratio of the Exports(as % of merchandise exports) in Czech Republic in 2007 to that in 2012?
Ensure brevity in your answer.  0.9. What is the ratio of the Exports(as % of merchandise exports) of Jordan in 2007 to that in 2012?
Provide a short and direct response. 1.61. What is the ratio of the Exports(as % of merchandise exports) of Peru in 2007 to that in 2012?
Make the answer very short. 1.32. What is the ratio of the Exports(as % of merchandise exports) of Algeria in 2008 to that in 2009?
Your response must be concise. 0.9. What is the ratio of the Exports(as % of merchandise exports) in Czech Republic in 2008 to that in 2009?
Offer a terse response. 0.9. What is the ratio of the Exports(as % of merchandise exports) of Jordan in 2008 to that in 2009?
Provide a short and direct response. 1.24. What is the ratio of the Exports(as % of merchandise exports) of Peru in 2008 to that in 2009?
Keep it short and to the point. 0.97. What is the ratio of the Exports(as % of merchandise exports) of Algeria in 2008 to that in 2010?
Your answer should be very brief. 0.42. What is the ratio of the Exports(as % of merchandise exports) of Czech Republic in 2008 to that in 2010?
Your response must be concise. 0.87. What is the ratio of the Exports(as % of merchandise exports) of Jordan in 2008 to that in 2010?
Give a very brief answer. 1.11. What is the ratio of the Exports(as % of merchandise exports) in Peru in 2008 to that in 2010?
Provide a succinct answer. 1.05. What is the ratio of the Exports(as % of merchandise exports) in Algeria in 2008 to that in 2011?
Make the answer very short. 0.27. What is the ratio of the Exports(as % of merchandise exports) of Czech Republic in 2008 to that in 2011?
Offer a terse response. 0.86. What is the ratio of the Exports(as % of merchandise exports) in Jordan in 2008 to that in 2011?
Your answer should be very brief. 1.18. What is the ratio of the Exports(as % of merchandise exports) in Peru in 2008 to that in 2011?
Offer a terse response. 1.21. What is the ratio of the Exports(as % of merchandise exports) of Algeria in 2008 to that in 2012?
Offer a very short reply. 0.67. What is the ratio of the Exports(as % of merchandise exports) in Czech Republic in 2008 to that in 2012?
Offer a very short reply. 0.84. What is the ratio of the Exports(as % of merchandise exports) of Jordan in 2008 to that in 2012?
Offer a terse response. 1.48. What is the ratio of the Exports(as % of merchandise exports) in Peru in 2008 to that in 2012?
Provide a succinct answer. 1.26. What is the ratio of the Exports(as % of merchandise exports) in Algeria in 2009 to that in 2010?
Offer a terse response. 0.47. What is the ratio of the Exports(as % of merchandise exports) of Czech Republic in 2009 to that in 2010?
Your response must be concise. 0.96. What is the ratio of the Exports(as % of merchandise exports) of Jordan in 2009 to that in 2010?
Your answer should be compact. 0.9. What is the ratio of the Exports(as % of merchandise exports) in Peru in 2009 to that in 2010?
Keep it short and to the point. 1.09. What is the ratio of the Exports(as % of merchandise exports) in Algeria in 2009 to that in 2011?
Keep it short and to the point. 0.3. What is the ratio of the Exports(as % of merchandise exports) of Czech Republic in 2009 to that in 2011?
Provide a succinct answer. 0.95. What is the ratio of the Exports(as % of merchandise exports) in Jordan in 2009 to that in 2011?
Offer a terse response. 0.96. What is the ratio of the Exports(as % of merchandise exports) of Peru in 2009 to that in 2011?
Keep it short and to the point. 1.25. What is the ratio of the Exports(as % of merchandise exports) in Algeria in 2009 to that in 2012?
Ensure brevity in your answer.  0.75. What is the ratio of the Exports(as % of merchandise exports) in Czech Republic in 2009 to that in 2012?
Your answer should be very brief. 0.93. What is the ratio of the Exports(as % of merchandise exports) in Jordan in 2009 to that in 2012?
Provide a short and direct response. 1.19. What is the ratio of the Exports(as % of merchandise exports) of Peru in 2009 to that in 2012?
Provide a short and direct response. 1.3. What is the ratio of the Exports(as % of merchandise exports) in Algeria in 2010 to that in 2011?
Your answer should be very brief. 0.64. What is the ratio of the Exports(as % of merchandise exports) of Jordan in 2010 to that in 2011?
Your answer should be very brief. 1.06. What is the ratio of the Exports(as % of merchandise exports) of Peru in 2010 to that in 2011?
Make the answer very short. 1.15. What is the ratio of the Exports(as % of merchandise exports) in Algeria in 2010 to that in 2012?
Your response must be concise. 1.61. What is the ratio of the Exports(as % of merchandise exports) in Czech Republic in 2010 to that in 2012?
Make the answer very short. 0.97. What is the ratio of the Exports(as % of merchandise exports) in Jordan in 2010 to that in 2012?
Your answer should be very brief. 1.32. What is the ratio of the Exports(as % of merchandise exports) in Peru in 2010 to that in 2012?
Make the answer very short. 1.2. What is the ratio of the Exports(as % of merchandise exports) of Algeria in 2011 to that in 2012?
Provide a succinct answer. 2.51. What is the ratio of the Exports(as % of merchandise exports) in Jordan in 2011 to that in 2012?
Your response must be concise. 1.25. What is the ratio of the Exports(as % of merchandise exports) of Peru in 2011 to that in 2012?
Keep it short and to the point. 1.04. What is the difference between the highest and the second highest Exports(as % of merchandise exports) in Algeria?
Make the answer very short. 0.01. What is the difference between the highest and the second highest Exports(as % of merchandise exports) of Czech Republic?
Provide a succinct answer. 0.03. What is the difference between the highest and the second highest Exports(as % of merchandise exports) in Jordan?
Keep it short and to the point. 0.02. What is the difference between the highest and the second highest Exports(as % of merchandise exports) of Peru?
Provide a short and direct response. 0.01. What is the difference between the highest and the lowest Exports(as % of merchandise exports) in Algeria?
Your response must be concise. 0.02. What is the difference between the highest and the lowest Exports(as % of merchandise exports) of Czech Republic?
Give a very brief answer. 0.24. What is the difference between the highest and the lowest Exports(as % of merchandise exports) of Jordan?
Offer a very short reply. 0.1. What is the difference between the highest and the lowest Exports(as % of merchandise exports) of Peru?
Provide a succinct answer. 0.35. 